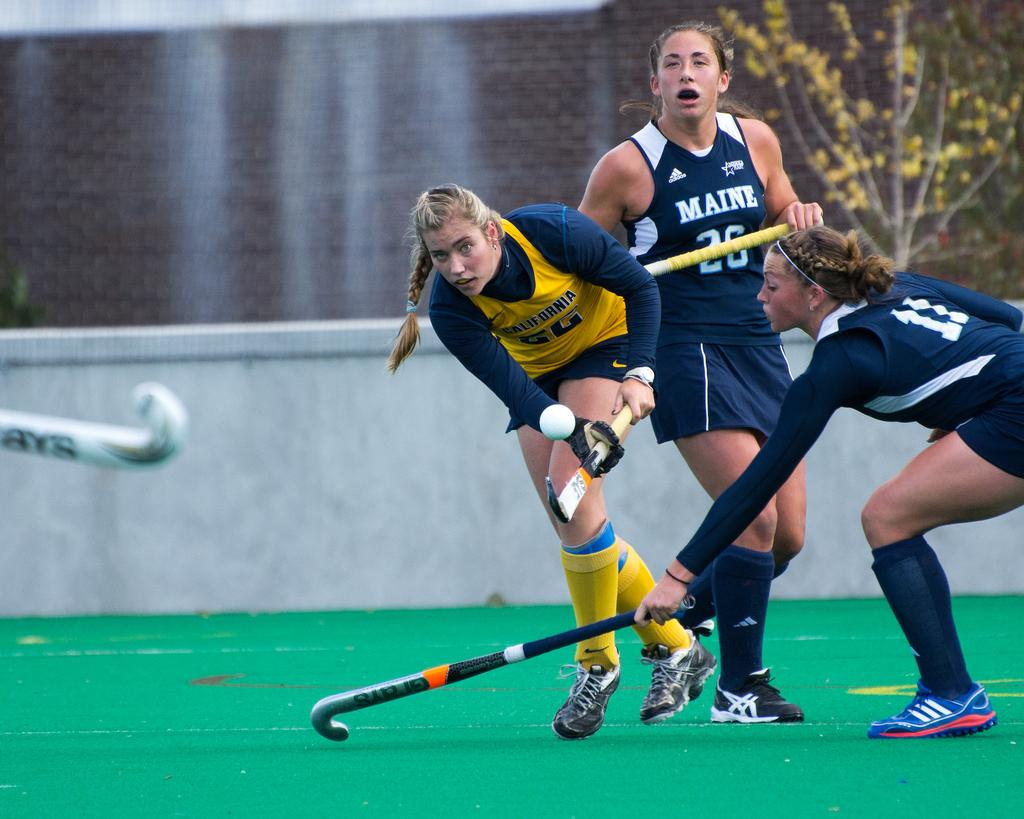Provide a one-sentence caption for the provided image. Girls from the state of Maine are playing indoor field hockey. 